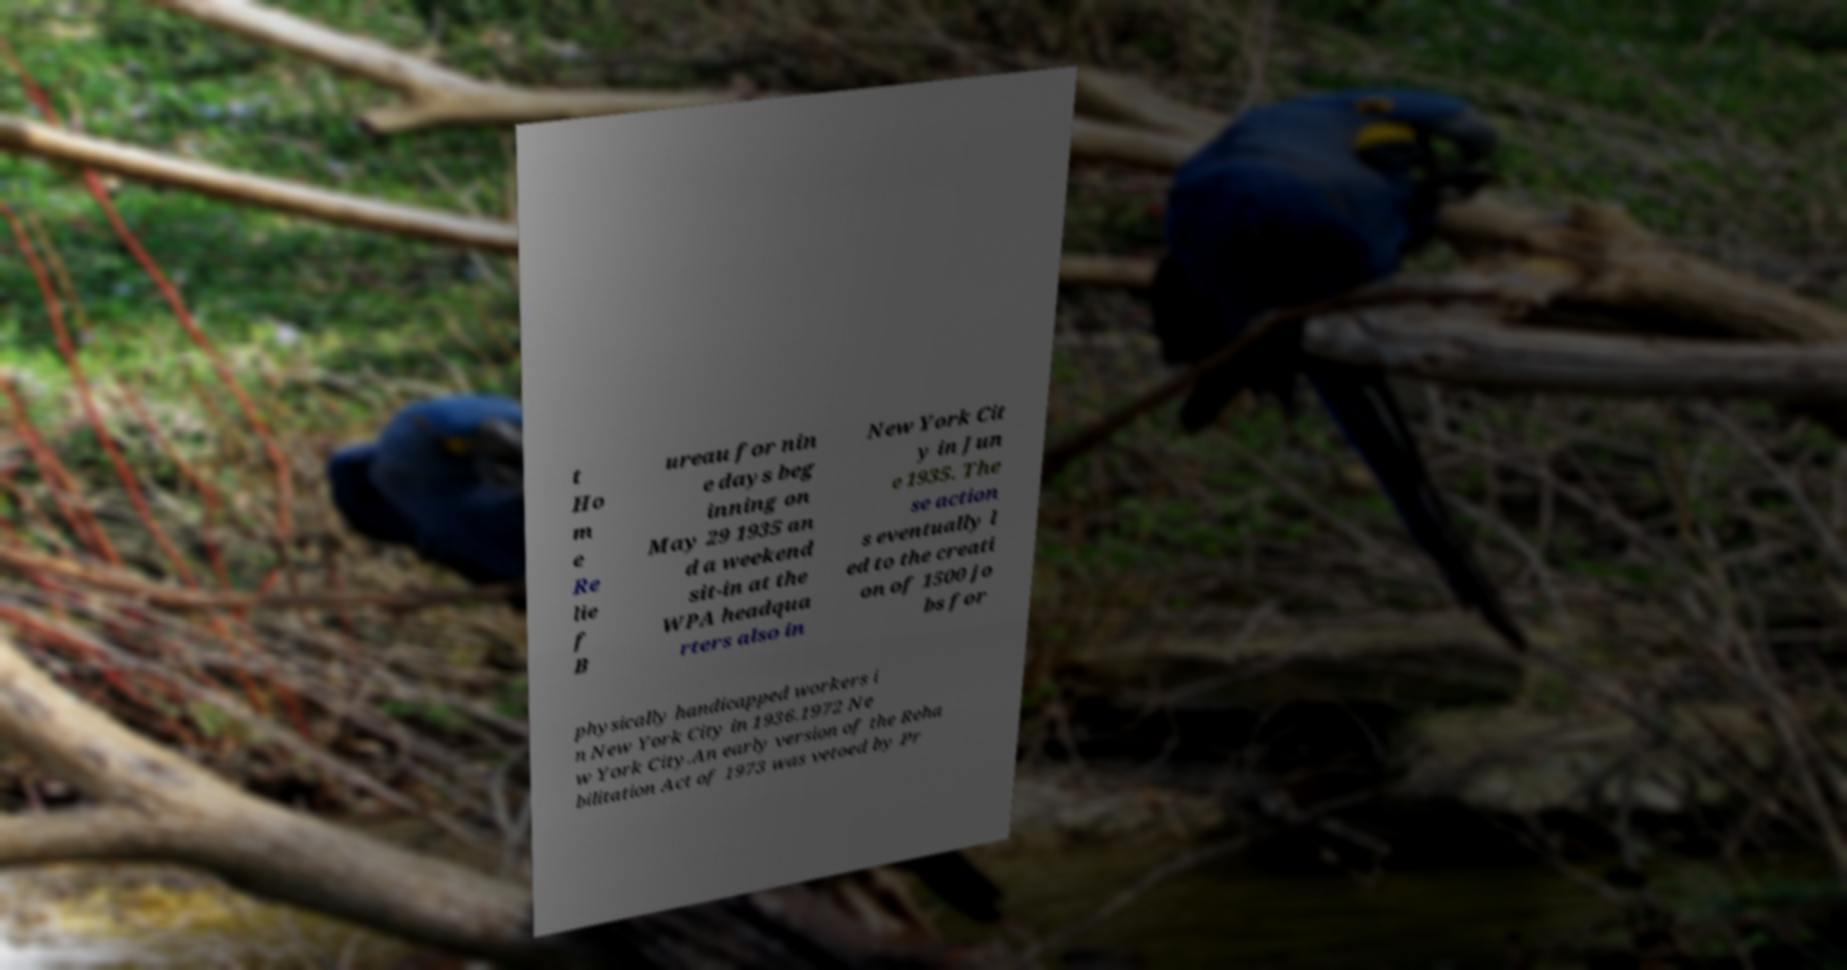I need the written content from this picture converted into text. Can you do that? t Ho m e Re lie f B ureau for nin e days beg inning on May 29 1935 an d a weekend sit-in at the WPA headqua rters also in New York Cit y in Jun e 1935. The se action s eventually l ed to the creati on of 1500 jo bs for physically handicapped workers i n New York City in 1936.1972 Ne w York City.An early version of the Reha bilitation Act of 1973 was vetoed by Pr 